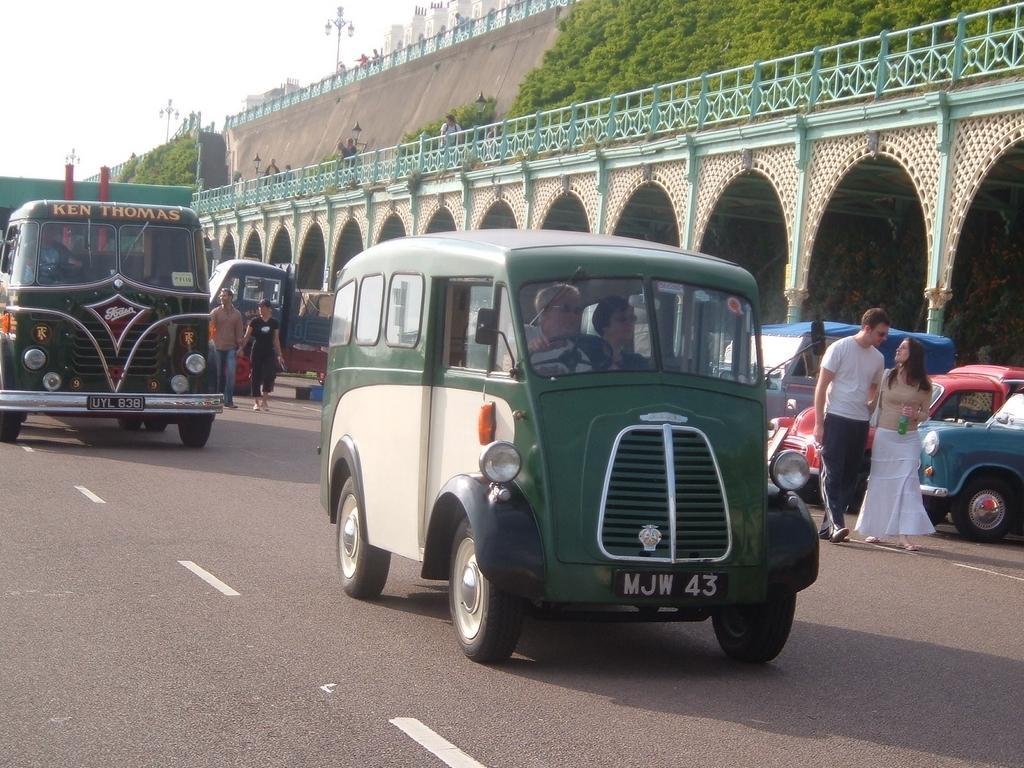How would you summarize this image in a sentence or two? In this image there are some vehicles in middle of this image and there is a building in the background. There are some persons standing on the left side of this image and right side of this image as well. There are some trees on the top right corner of this image. There is a road in the bottom of this image and there is a sky on the top of this image. 